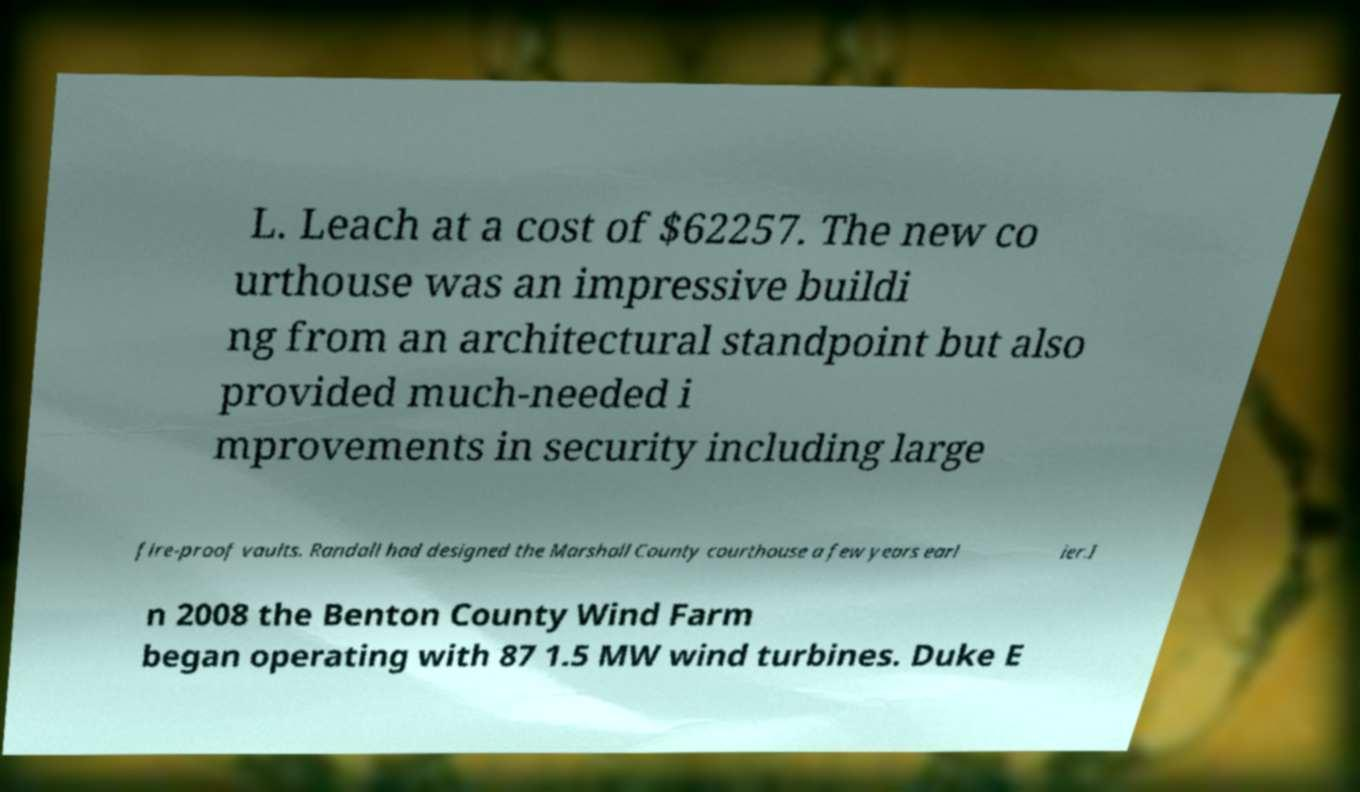What messages or text are displayed in this image? I need them in a readable, typed format. L. Leach at a cost of $62257. The new co urthouse was an impressive buildi ng from an architectural standpoint but also provided much-needed i mprovements in security including large fire-proof vaults. Randall had designed the Marshall County courthouse a few years earl ier.I n 2008 the Benton County Wind Farm began operating with 87 1.5 MW wind turbines. Duke E 